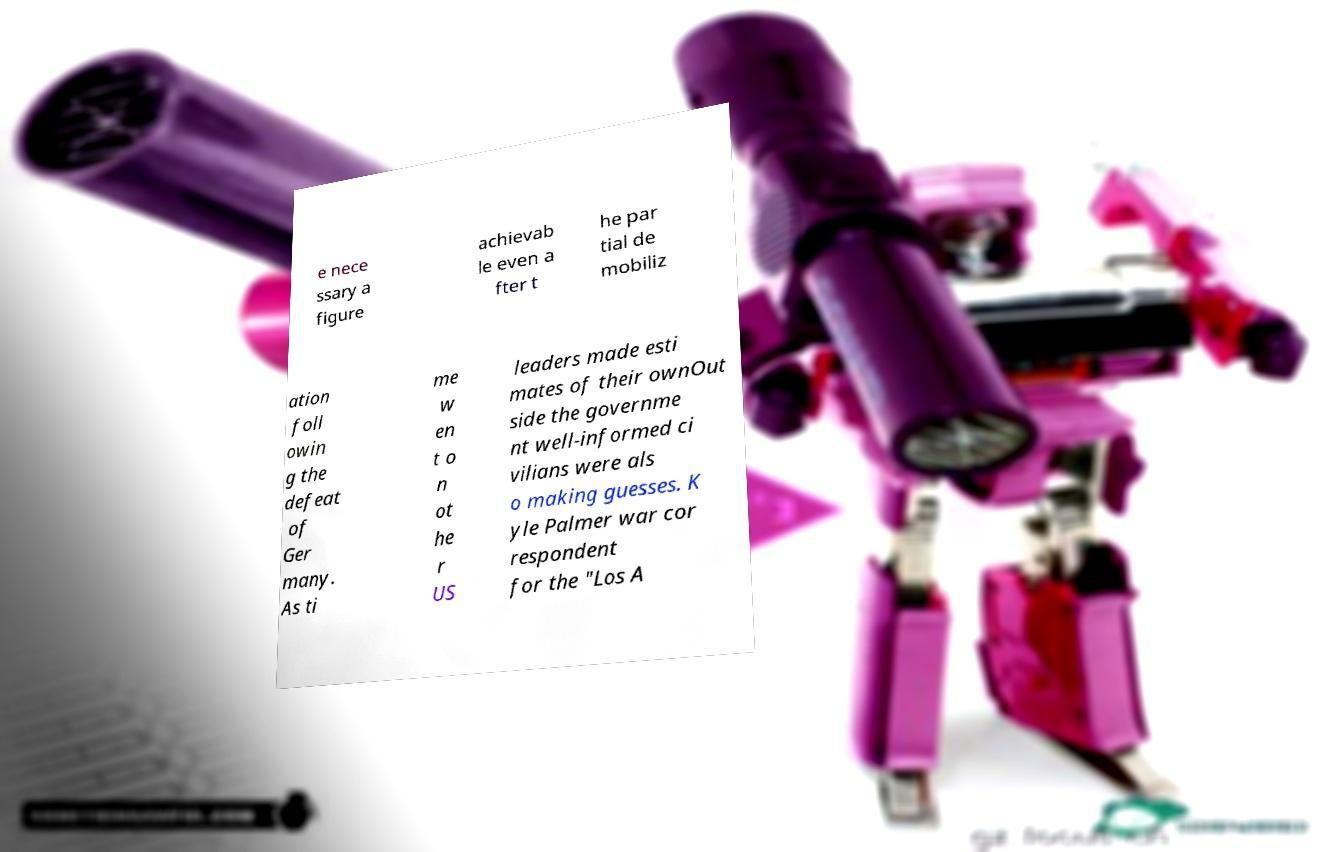Could you assist in decoding the text presented in this image and type it out clearly? e nece ssary a figure achievab le even a fter t he par tial de mobiliz ation foll owin g the defeat of Ger many. As ti me w en t o n ot he r US leaders made esti mates of their ownOut side the governme nt well-informed ci vilians were als o making guesses. K yle Palmer war cor respondent for the "Los A 